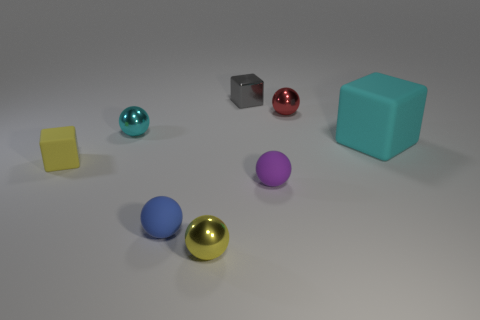Subtract all small yellow spheres. How many spheres are left? 4 Subtract 2 spheres. How many spheres are left? 3 Add 2 shiny balls. How many objects exist? 10 Subtract all yellow spheres. How many spheres are left? 4 Subtract all balls. How many objects are left? 3 Subtract all purple balls. Subtract all yellow cylinders. How many balls are left? 4 Subtract all large purple metallic cubes. Subtract all cyan metallic objects. How many objects are left? 7 Add 5 yellow spheres. How many yellow spheres are left? 6 Add 7 blue shiny cylinders. How many blue shiny cylinders exist? 7 Subtract 0 purple cylinders. How many objects are left? 8 